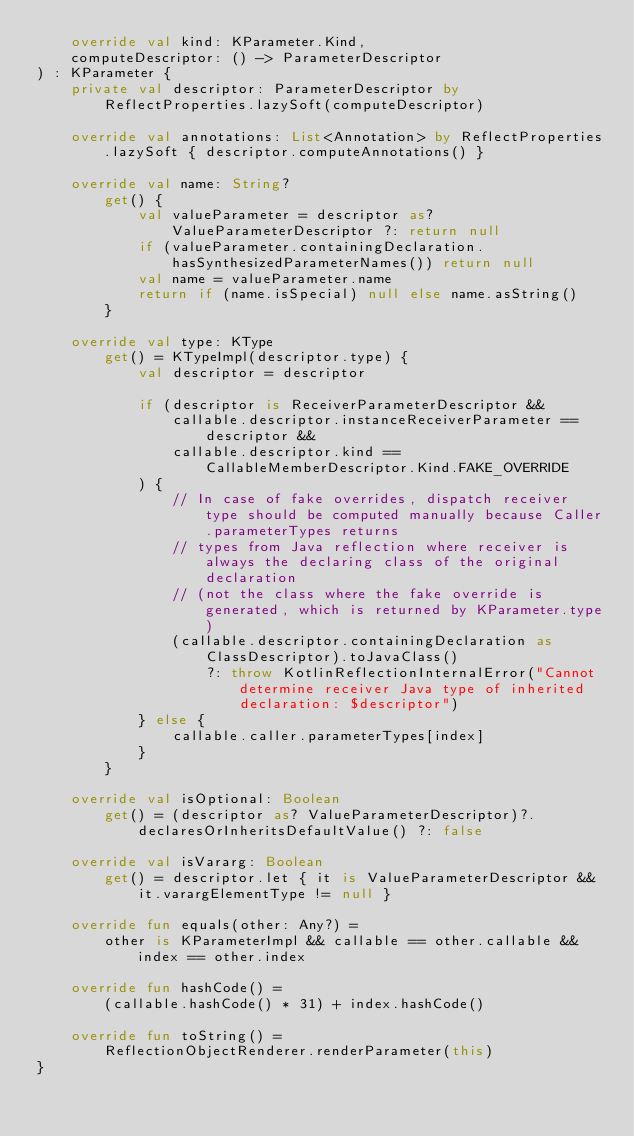Convert code to text. <code><loc_0><loc_0><loc_500><loc_500><_Kotlin_>    override val kind: KParameter.Kind,
    computeDescriptor: () -> ParameterDescriptor
) : KParameter {
    private val descriptor: ParameterDescriptor by ReflectProperties.lazySoft(computeDescriptor)

    override val annotations: List<Annotation> by ReflectProperties.lazySoft { descriptor.computeAnnotations() }

    override val name: String?
        get() {
            val valueParameter = descriptor as? ValueParameterDescriptor ?: return null
            if (valueParameter.containingDeclaration.hasSynthesizedParameterNames()) return null
            val name = valueParameter.name
            return if (name.isSpecial) null else name.asString()
        }

    override val type: KType
        get() = KTypeImpl(descriptor.type) {
            val descriptor = descriptor

            if (descriptor is ReceiverParameterDescriptor &&
                callable.descriptor.instanceReceiverParameter == descriptor &&
                callable.descriptor.kind == CallableMemberDescriptor.Kind.FAKE_OVERRIDE
            ) {
                // In case of fake overrides, dispatch receiver type should be computed manually because Caller.parameterTypes returns
                // types from Java reflection where receiver is always the declaring class of the original declaration
                // (not the class where the fake override is generated, which is returned by KParameter.type)
                (callable.descriptor.containingDeclaration as ClassDescriptor).toJavaClass()
                    ?: throw KotlinReflectionInternalError("Cannot determine receiver Java type of inherited declaration: $descriptor")
            } else {
                callable.caller.parameterTypes[index]
            }
        }

    override val isOptional: Boolean
        get() = (descriptor as? ValueParameterDescriptor)?.declaresOrInheritsDefaultValue() ?: false

    override val isVararg: Boolean
        get() = descriptor.let { it is ValueParameterDescriptor && it.varargElementType != null }

    override fun equals(other: Any?) =
        other is KParameterImpl && callable == other.callable && index == other.index

    override fun hashCode() =
        (callable.hashCode() * 31) + index.hashCode()

    override fun toString() =
        ReflectionObjectRenderer.renderParameter(this)
}
</code> 